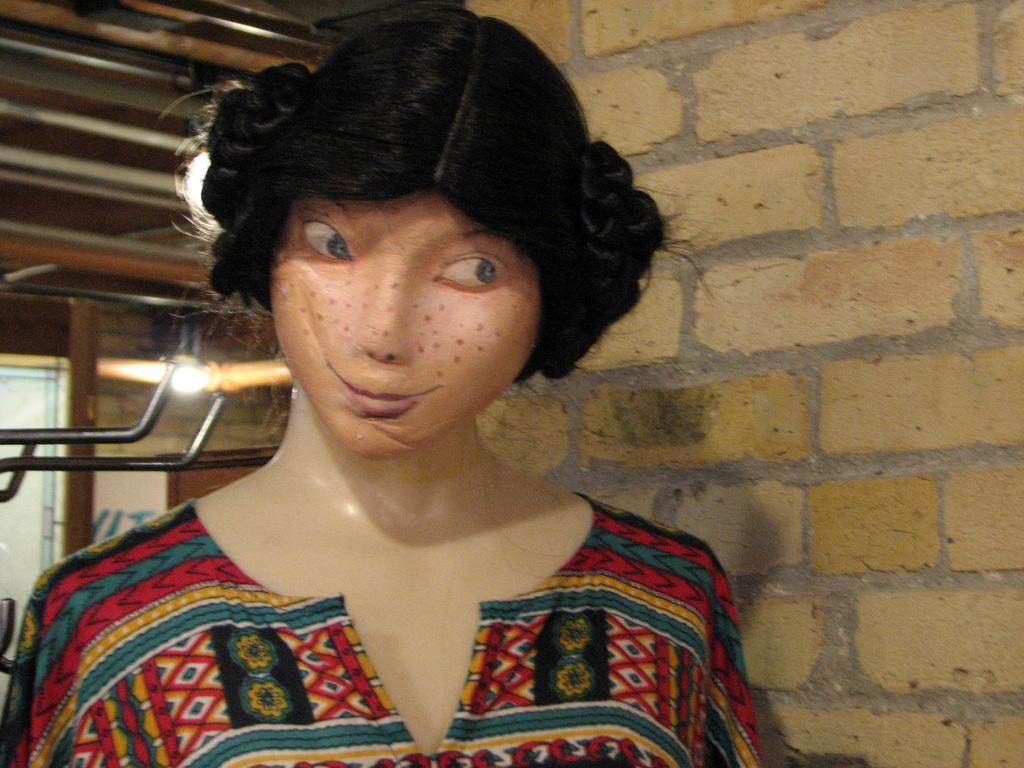Please provide a concise description of this image. In this image I can see the mannequin with colorful dress. In the background I can see the brick wall, light and some rods. 